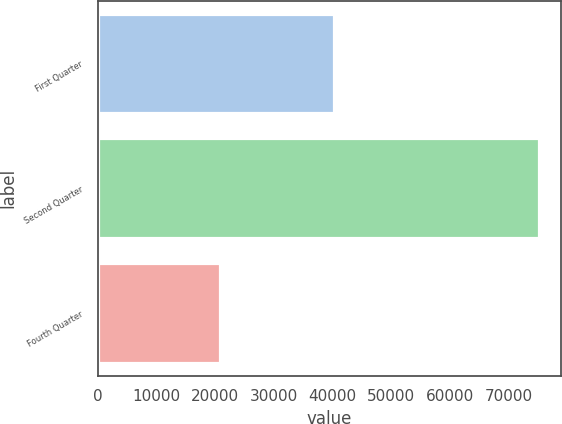Convert chart. <chart><loc_0><loc_0><loc_500><loc_500><bar_chart><fcel>First Quarter<fcel>Second Quarter<fcel>Fourth Quarter<nl><fcel>40298<fcel>75103<fcel>20800<nl></chart> 